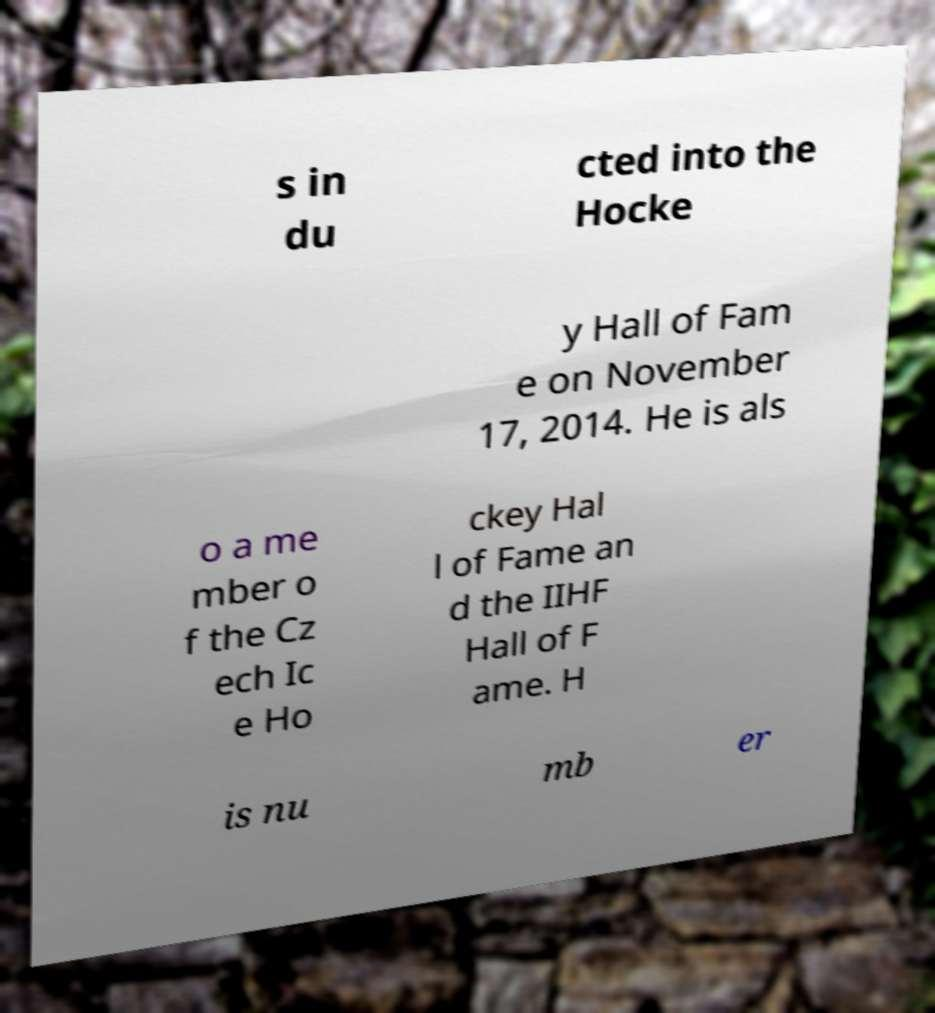What messages or text are displayed in this image? I need them in a readable, typed format. s in du cted into the Hocke y Hall of Fam e on November 17, 2014. He is als o a me mber o f the Cz ech Ic e Ho ckey Hal l of Fame an d the IIHF Hall of F ame. H is nu mb er 